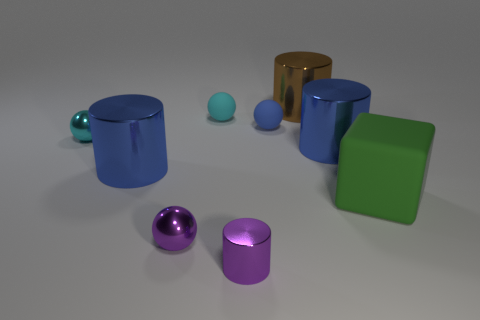Subtract all brown cylinders. How many cylinders are left? 3 Subtract all brown cylinders. How many cylinders are left? 3 Subtract all cylinders. How many objects are left? 5 Subtract 2 balls. How many balls are left? 2 Add 2 tiny balls. How many tiny balls are left? 6 Add 6 tiny blue matte balls. How many tiny blue matte balls exist? 7 Add 1 large blue things. How many objects exist? 10 Subtract 0 cyan blocks. How many objects are left? 9 Subtract all yellow cubes. Subtract all blue cylinders. How many cubes are left? 1 Subtract all red balls. How many yellow blocks are left? 0 